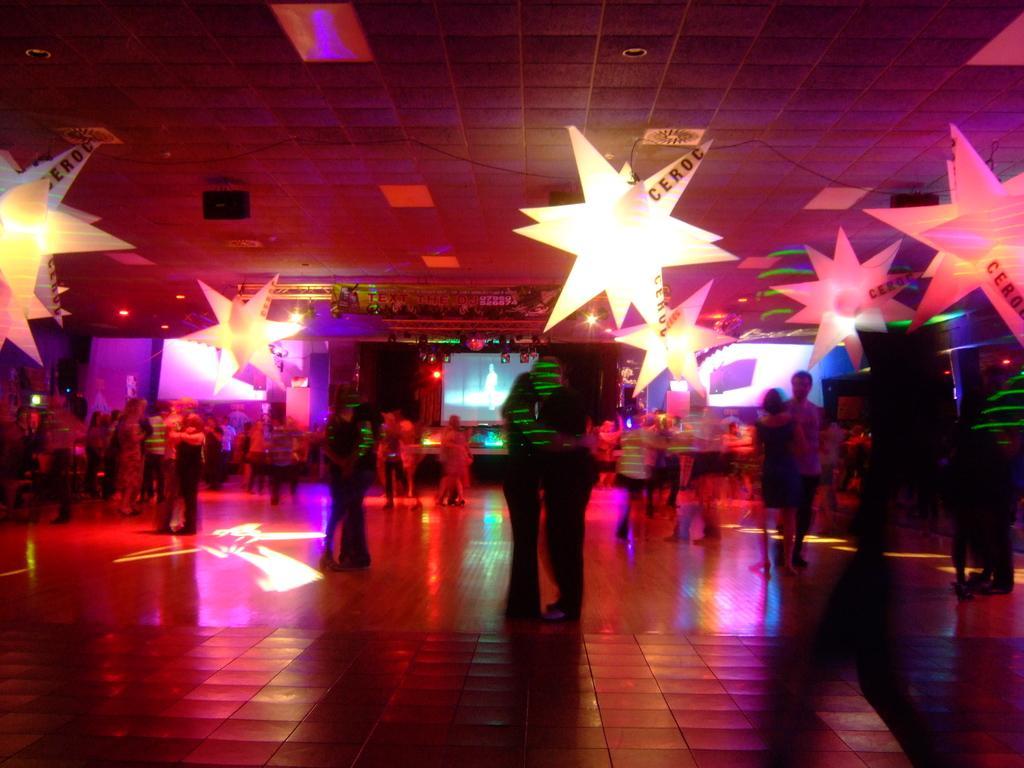Please provide a concise description of this image. In this image, we can see persons standing and wearing clothes. There are decors hanging from the ceiling which is at the top of the image. There is a screen in the middle of the image. 